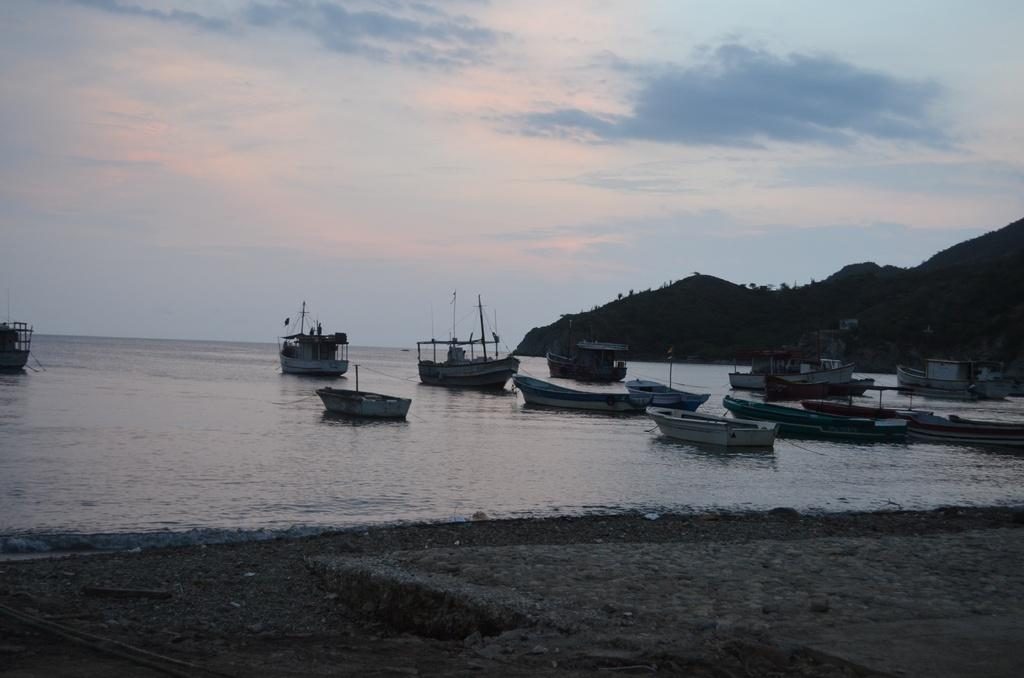What can be seen at the bottom of the image? The ground is visible in the image. What is on the water in the image? There are boats on the water in the image. What can be seen in the distance in the image? There are mountains in the background of the image. What is visible above the mountains in the image? The sky is visible in the background of the image. How much wealth is displayed in the image? There is no indication of wealth in the image; it features boats on the water, mountains in the background, and the sky. What type of wave can be seen crashing on the shore in the image? There is no wave visible in the image; it features boats on the water, mountains in the background, and the sky. 